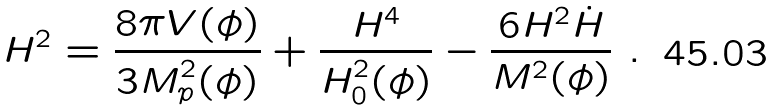Convert formula to latex. <formula><loc_0><loc_0><loc_500><loc_500>H ^ { 2 } = { \frac { 8 \pi V ( \phi ) } { 3 M _ { p } ^ { 2 } ( \phi ) } } + { \frac { H ^ { 4 } } { H _ { 0 } ^ { 2 } ( \phi ) } } - { \frac { 6 H ^ { 2 } \dot { H } } { M ^ { 2 } ( \phi ) } } \ .</formula> 